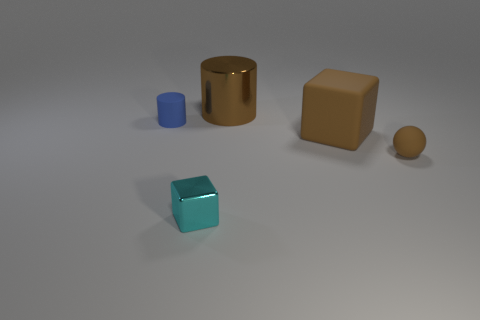Add 1 tiny rubber cylinders. How many objects exist? 6 Subtract all blocks. How many objects are left? 3 Subtract all big rubber things. Subtract all large gray cylinders. How many objects are left? 4 Add 1 tiny metal things. How many tiny metal things are left? 2 Add 3 small brown matte spheres. How many small brown matte spheres exist? 4 Subtract 0 blue spheres. How many objects are left? 5 